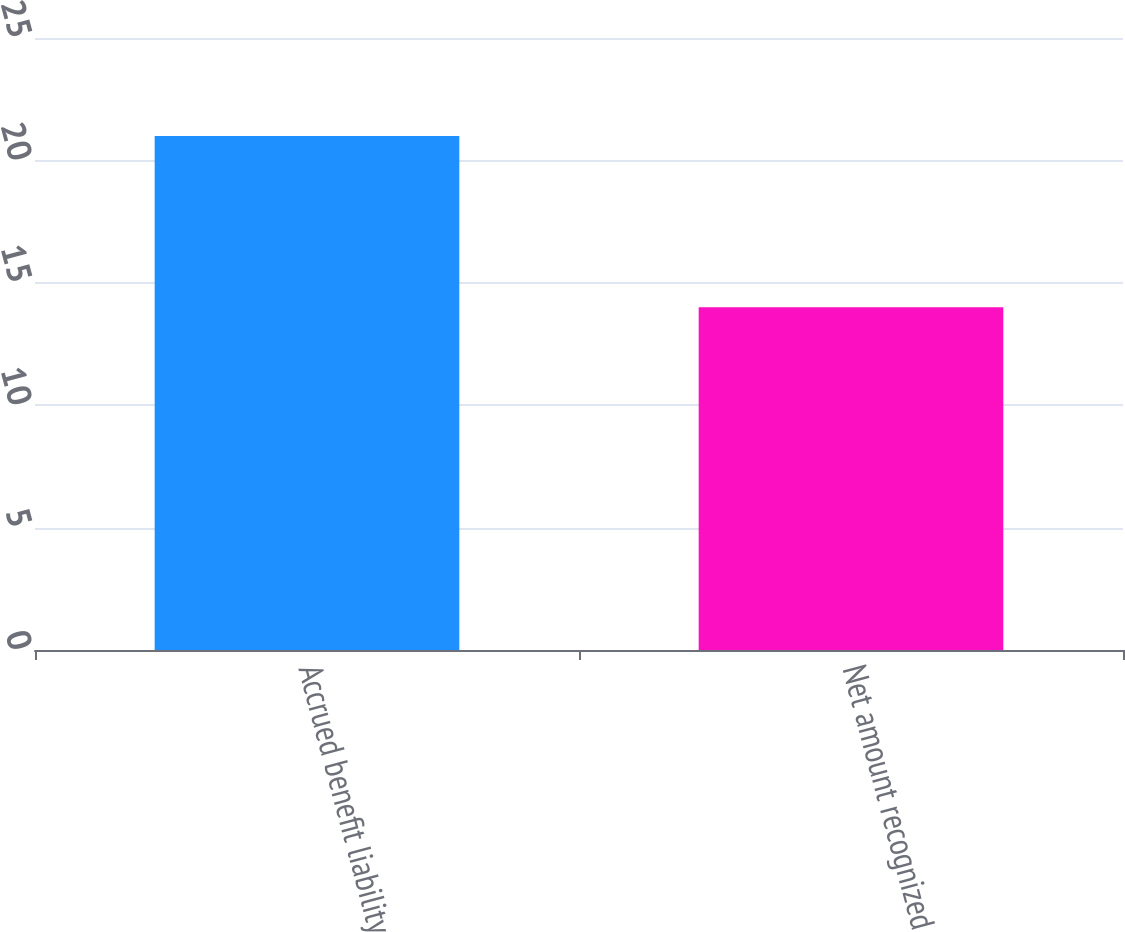<chart> <loc_0><loc_0><loc_500><loc_500><bar_chart><fcel>Accrued benefit liability<fcel>Net amount recognized<nl><fcel>21<fcel>14<nl></chart> 